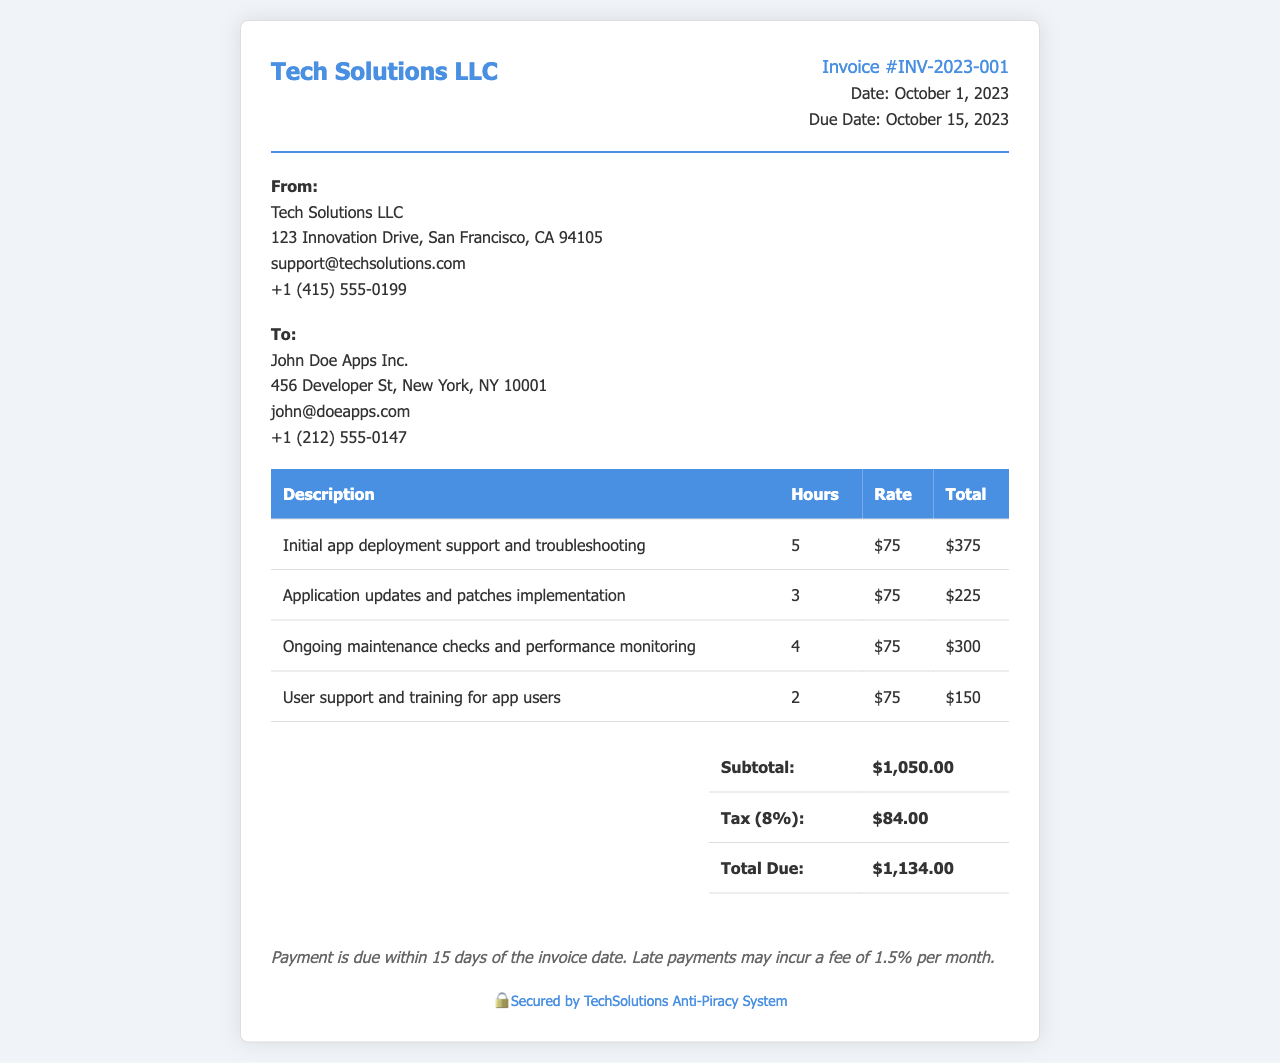What is the invoice number? The invoice number is explicitly stated in the document as Invoice #INV-2023-001.
Answer: Invoice #INV-2023-001 When is the due date for the invoice? The due date is provided in the document as October 15, 2023.
Answer: October 15, 2023 How many hours were spent on ongoing maintenance checks? The document specifies that 4 hours were spent on ongoing maintenance checks and performance monitoring.
Answer: 4 What is the total due amount? The total amount due is listed in the summary section as $1,134.00.
Answer: $1,134.00 What service had the highest total cost? The service with the highest total cost in the list is the initial app deployment support and troubleshooting, totaling $375.
Answer: Initial app deployment support and troubleshooting What is the subtotal before tax? The subtotal amount is given in the summary table as $1,050.00.
Answer: $1,050.00 What is the tax percentage applied to the invoice? The tax percentage calculated in the document is 8%.
Answer: 8% Who is the contact person for the service provider? The document does not explicitly state a contact person; it only includes the company name and contact details.
Answer: Tech Solutions LLC What is the payment term stated in the invoice? The payment terms are described as due within 15 days of the invoice date.
Answer: 15 days 